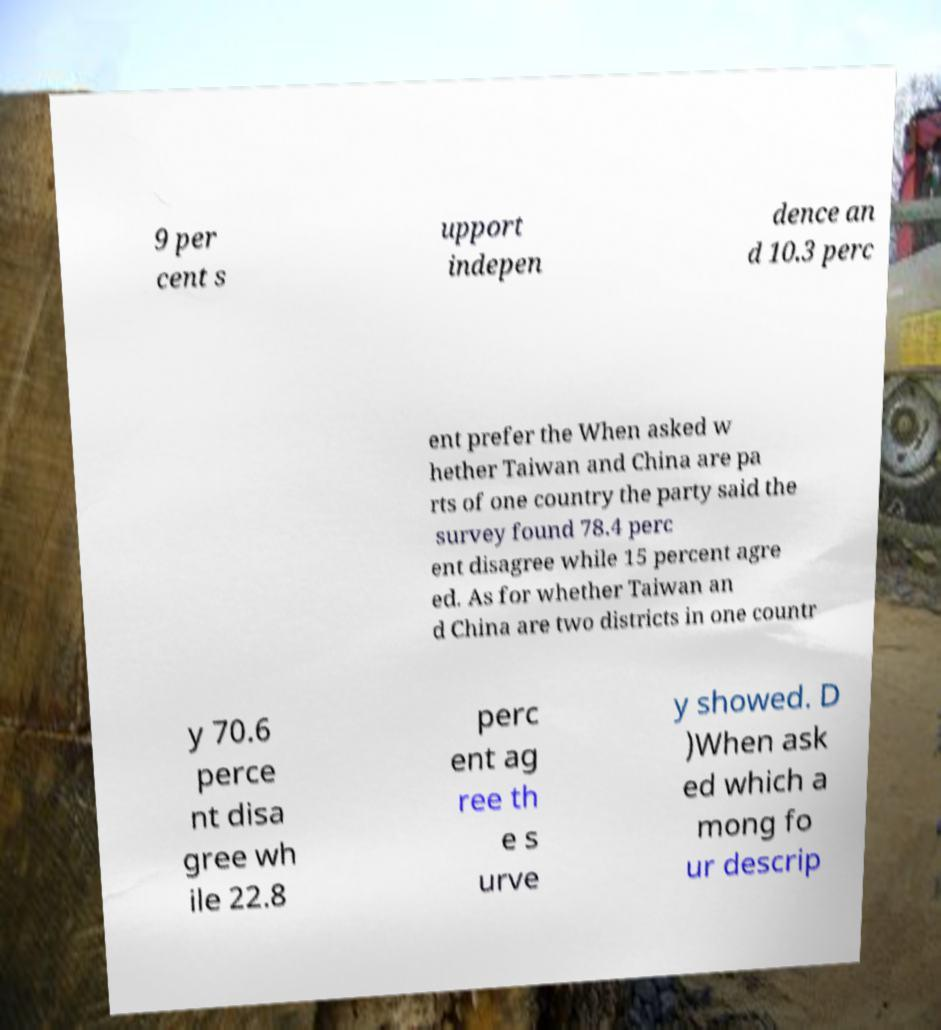Can you accurately transcribe the text from the provided image for me? 9 per cent s upport indepen dence an d 10.3 perc ent prefer the When asked w hether Taiwan and China are pa rts of one country the party said the survey found 78.4 perc ent disagree while 15 percent agre ed. As for whether Taiwan an d China are two districts in one countr y 70.6 perce nt disa gree wh ile 22.8 perc ent ag ree th e s urve y showed. D )When ask ed which a mong fo ur descrip 